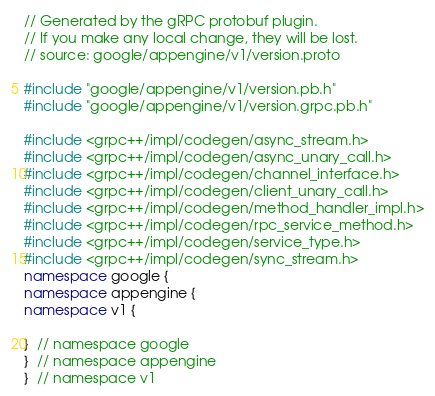<code> <loc_0><loc_0><loc_500><loc_500><_C++_>// Generated by the gRPC protobuf plugin.
// If you make any local change, they will be lost.
// source: google/appengine/v1/version.proto

#include "google/appengine/v1/version.pb.h"
#include "google/appengine/v1/version.grpc.pb.h"

#include <grpc++/impl/codegen/async_stream.h>
#include <grpc++/impl/codegen/async_unary_call.h>
#include <grpc++/impl/codegen/channel_interface.h>
#include <grpc++/impl/codegen/client_unary_call.h>
#include <grpc++/impl/codegen/method_handler_impl.h>
#include <grpc++/impl/codegen/rpc_service_method.h>
#include <grpc++/impl/codegen/service_type.h>
#include <grpc++/impl/codegen/sync_stream.h>
namespace google {
namespace appengine {
namespace v1 {

}  // namespace google
}  // namespace appengine
}  // namespace v1

</code> 